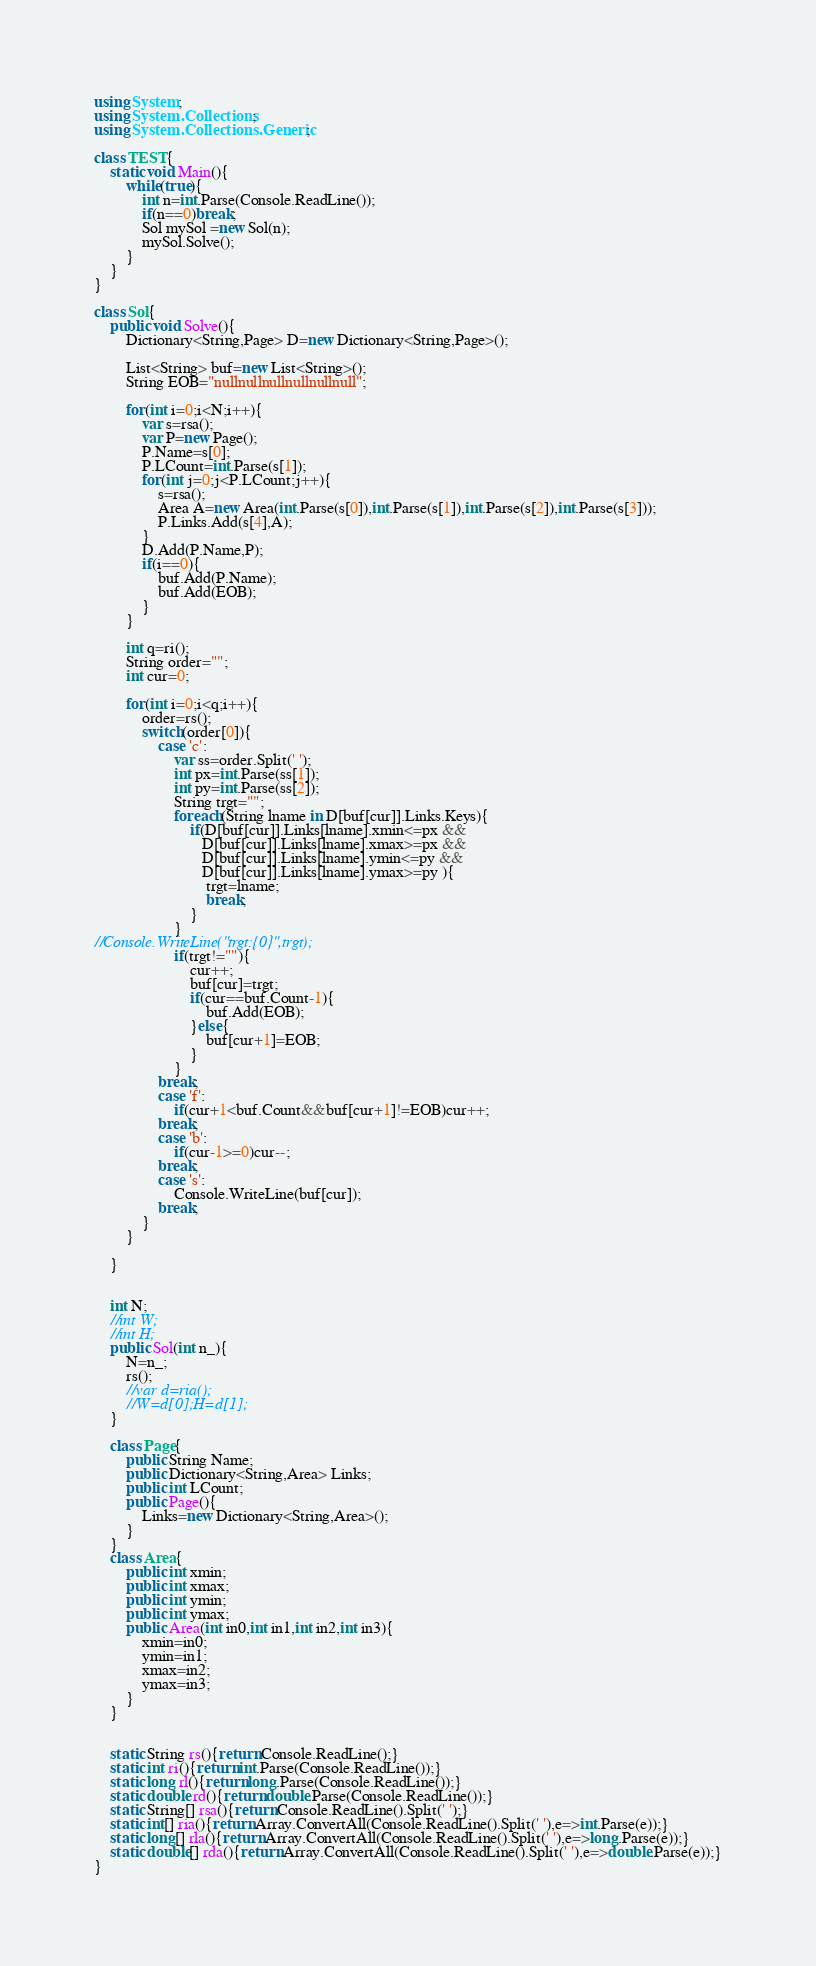<code> <loc_0><loc_0><loc_500><loc_500><_C#_>using System;
using System.Collections;
using System.Collections.Generic;
 
class TEST{
	static void Main(){
		while(true){
			int n=int.Parse(Console.ReadLine());
			if(n==0)break;
			Sol mySol =new Sol(n);
			mySol.Solve();
		}
	}
}

class Sol{
	public void Solve(){
		Dictionary<String,Page> D=new Dictionary<String,Page>();
		
		List<String> buf=new List<String>();
		String EOB="nullnullnullnullnullnull";
		
		for(int i=0;i<N;i++){
			var s=rsa();
			var P=new Page();
			P.Name=s[0];
			P.LCount=int.Parse(s[1]);
			for(int j=0;j<P.LCount;j++){
				s=rsa();
				Area A=new Area(int.Parse(s[0]),int.Parse(s[1]),int.Parse(s[2]),int.Parse(s[3]));
				P.Links.Add(s[4],A);
			}
			D.Add(P.Name,P);
			if(i==0){
				buf.Add(P.Name);
				buf.Add(EOB);
			}
		}
		
		int q=ri();
		String order="";
		int cur=0;
		
		for(int i=0;i<q;i++){
			order=rs();
			switch(order[0]){
				case 'c':
					var ss=order.Split(' ');
					int px=int.Parse(ss[1]);
					int py=int.Parse(ss[2]);
					String trgt="";
					foreach(String lname in D[buf[cur]].Links.Keys){
						if(D[buf[cur]].Links[lname].xmin<=px &&
						   D[buf[cur]].Links[lname].xmax>=px &&
						   D[buf[cur]].Links[lname].ymin<=py &&
						   D[buf[cur]].Links[lname].ymax>=py ){
							trgt=lname;
							break;
						}
					}
//Console.WriteLine("trgt:{0}",trgt);
					if(trgt!=""){
						cur++;
						buf[cur]=trgt;
						if(cur==buf.Count-1){
							buf.Add(EOB);
						}else{
							buf[cur+1]=EOB;
						}
					}
				break;
				case 'f':
					if(cur+1<buf.Count&&buf[cur+1]!=EOB)cur++;
				break;
				case 'b':
					if(cur-1>=0)cur--;
				break;
				case 's':
					Console.WriteLine(buf[cur]);
				break;
			}
		}
		
	}
	

	int N;
	//int W;
	//int H;
	public Sol(int n_){
		N=n_;
		rs();
		//var d=ria();
		//W=d[0];H=d[1];
	}

	class Page{
		public String Name;
		public Dictionary<String,Area> Links;
		public int LCount;
		public Page(){
			Links=new Dictionary<String,Area>();
		}
	}
	class Area{
		public int xmin;
		public int xmax;
		public int ymin;
		public int ymax;
		public Area(int in0,int in1,int in2,int in3){
			xmin=in0;
			ymin=in1;
			xmax=in2;
			ymax=in3;
		}
	}


	static String rs(){return Console.ReadLine();}
	static int ri(){return int.Parse(Console.ReadLine());}
	static long rl(){return long.Parse(Console.ReadLine());}
	static double rd(){return double.Parse(Console.ReadLine());}
	static String[] rsa(){return Console.ReadLine().Split(' ');}
	static int[] ria(){return Array.ConvertAll(Console.ReadLine().Split(' '),e=>int.Parse(e));}
	static long[] rla(){return Array.ConvertAll(Console.ReadLine().Split(' '),e=>long.Parse(e));}
	static double[] rda(){return Array.ConvertAll(Console.ReadLine().Split(' '),e=>double.Parse(e));}
}</code> 